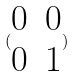<formula> <loc_0><loc_0><loc_500><loc_500>( \begin{matrix} 0 & 0 \\ 0 & 1 \end{matrix} )</formula> 